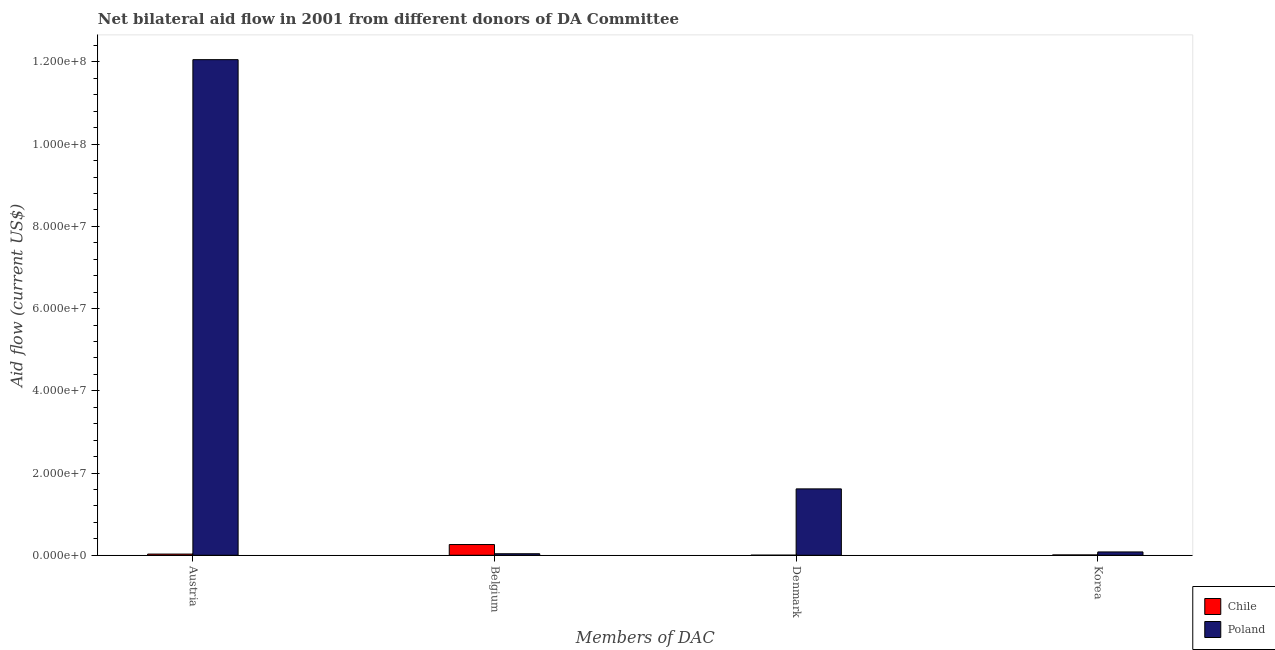How many different coloured bars are there?
Offer a very short reply. 2. Are the number of bars per tick equal to the number of legend labels?
Your answer should be very brief. Yes. How many bars are there on the 3rd tick from the right?
Your answer should be compact. 2. What is the amount of aid given by belgium in Chile?
Your answer should be very brief. 2.61e+06. Across all countries, what is the maximum amount of aid given by austria?
Give a very brief answer. 1.21e+08. Across all countries, what is the minimum amount of aid given by korea?
Keep it short and to the point. 8.00e+04. In which country was the amount of aid given by korea maximum?
Offer a terse response. Poland. In which country was the amount of aid given by belgium minimum?
Offer a very short reply. Poland. What is the total amount of aid given by korea in the graph?
Provide a short and direct response. 8.90e+05. What is the difference between the amount of aid given by denmark in Chile and that in Poland?
Ensure brevity in your answer.  -1.61e+07. What is the difference between the amount of aid given by austria in Poland and the amount of aid given by korea in Chile?
Your answer should be very brief. 1.20e+08. What is the average amount of aid given by korea per country?
Your response must be concise. 4.45e+05. What is the difference between the amount of aid given by belgium and amount of aid given by korea in Poland?
Provide a short and direct response. -4.40e+05. In how many countries, is the amount of aid given by austria greater than 80000000 US$?
Offer a very short reply. 1. What is the ratio of the amount of aid given by belgium in Poland to that in Chile?
Provide a short and direct response. 0.14. Is the difference between the amount of aid given by belgium in Poland and Chile greater than the difference between the amount of aid given by denmark in Poland and Chile?
Your response must be concise. No. What is the difference between the highest and the second highest amount of aid given by denmark?
Offer a terse response. 1.61e+07. What is the difference between the highest and the lowest amount of aid given by denmark?
Provide a succinct answer. 1.61e+07. Is it the case that in every country, the sum of the amount of aid given by korea and amount of aid given by austria is greater than the sum of amount of aid given by denmark and amount of aid given by belgium?
Keep it short and to the point. No. What does the 1st bar from the right in Belgium represents?
Give a very brief answer. Poland. How many bars are there?
Keep it short and to the point. 8. What is the difference between two consecutive major ticks on the Y-axis?
Your response must be concise. 2.00e+07. Are the values on the major ticks of Y-axis written in scientific E-notation?
Give a very brief answer. Yes. Where does the legend appear in the graph?
Keep it short and to the point. Bottom right. How are the legend labels stacked?
Your response must be concise. Vertical. What is the title of the graph?
Make the answer very short. Net bilateral aid flow in 2001 from different donors of DA Committee. What is the label or title of the X-axis?
Your answer should be compact. Members of DAC. What is the Aid flow (current US$) in Poland in Austria?
Give a very brief answer. 1.21e+08. What is the Aid flow (current US$) in Chile in Belgium?
Keep it short and to the point. 2.61e+06. What is the Aid flow (current US$) of Chile in Denmark?
Keep it short and to the point. 2.00e+04. What is the Aid flow (current US$) of Poland in Denmark?
Offer a very short reply. 1.62e+07. What is the Aid flow (current US$) of Poland in Korea?
Make the answer very short. 8.10e+05. Across all Members of DAC, what is the maximum Aid flow (current US$) of Chile?
Give a very brief answer. 2.61e+06. Across all Members of DAC, what is the maximum Aid flow (current US$) in Poland?
Offer a very short reply. 1.21e+08. What is the total Aid flow (current US$) of Poland in the graph?
Offer a terse response. 1.38e+08. What is the difference between the Aid flow (current US$) in Chile in Austria and that in Belgium?
Your response must be concise. -2.32e+06. What is the difference between the Aid flow (current US$) of Poland in Austria and that in Belgium?
Provide a short and direct response. 1.20e+08. What is the difference between the Aid flow (current US$) in Chile in Austria and that in Denmark?
Make the answer very short. 2.70e+05. What is the difference between the Aid flow (current US$) of Poland in Austria and that in Denmark?
Offer a very short reply. 1.04e+08. What is the difference between the Aid flow (current US$) of Poland in Austria and that in Korea?
Give a very brief answer. 1.20e+08. What is the difference between the Aid flow (current US$) of Chile in Belgium and that in Denmark?
Ensure brevity in your answer.  2.59e+06. What is the difference between the Aid flow (current US$) in Poland in Belgium and that in Denmark?
Your response must be concise. -1.58e+07. What is the difference between the Aid flow (current US$) in Chile in Belgium and that in Korea?
Make the answer very short. 2.53e+06. What is the difference between the Aid flow (current US$) in Poland in Belgium and that in Korea?
Your answer should be compact. -4.40e+05. What is the difference between the Aid flow (current US$) of Poland in Denmark and that in Korea?
Your answer should be very brief. 1.53e+07. What is the difference between the Aid flow (current US$) of Chile in Austria and the Aid flow (current US$) of Poland in Belgium?
Offer a very short reply. -8.00e+04. What is the difference between the Aid flow (current US$) in Chile in Austria and the Aid flow (current US$) in Poland in Denmark?
Give a very brief answer. -1.59e+07. What is the difference between the Aid flow (current US$) in Chile in Austria and the Aid flow (current US$) in Poland in Korea?
Your response must be concise. -5.20e+05. What is the difference between the Aid flow (current US$) in Chile in Belgium and the Aid flow (current US$) in Poland in Denmark?
Make the answer very short. -1.35e+07. What is the difference between the Aid flow (current US$) in Chile in Belgium and the Aid flow (current US$) in Poland in Korea?
Offer a terse response. 1.80e+06. What is the difference between the Aid flow (current US$) of Chile in Denmark and the Aid flow (current US$) of Poland in Korea?
Offer a very short reply. -7.90e+05. What is the average Aid flow (current US$) in Chile per Members of DAC?
Keep it short and to the point. 7.50e+05. What is the average Aid flow (current US$) in Poland per Members of DAC?
Your response must be concise. 3.45e+07. What is the difference between the Aid flow (current US$) of Chile and Aid flow (current US$) of Poland in Austria?
Provide a succinct answer. -1.20e+08. What is the difference between the Aid flow (current US$) in Chile and Aid flow (current US$) in Poland in Belgium?
Make the answer very short. 2.24e+06. What is the difference between the Aid flow (current US$) of Chile and Aid flow (current US$) of Poland in Denmark?
Offer a terse response. -1.61e+07. What is the difference between the Aid flow (current US$) in Chile and Aid flow (current US$) in Poland in Korea?
Offer a very short reply. -7.30e+05. What is the ratio of the Aid flow (current US$) of Poland in Austria to that in Belgium?
Offer a very short reply. 325.86. What is the ratio of the Aid flow (current US$) in Chile in Austria to that in Denmark?
Offer a very short reply. 14.5. What is the ratio of the Aid flow (current US$) of Poland in Austria to that in Denmark?
Give a very brief answer. 7.47. What is the ratio of the Aid flow (current US$) in Chile in Austria to that in Korea?
Your answer should be compact. 3.62. What is the ratio of the Aid flow (current US$) of Poland in Austria to that in Korea?
Give a very brief answer. 148.85. What is the ratio of the Aid flow (current US$) of Chile in Belgium to that in Denmark?
Make the answer very short. 130.5. What is the ratio of the Aid flow (current US$) in Poland in Belgium to that in Denmark?
Provide a short and direct response. 0.02. What is the ratio of the Aid flow (current US$) in Chile in Belgium to that in Korea?
Your response must be concise. 32.62. What is the ratio of the Aid flow (current US$) of Poland in Belgium to that in Korea?
Ensure brevity in your answer.  0.46. What is the ratio of the Aid flow (current US$) in Chile in Denmark to that in Korea?
Ensure brevity in your answer.  0.25. What is the ratio of the Aid flow (current US$) of Poland in Denmark to that in Korea?
Offer a terse response. 19.94. What is the difference between the highest and the second highest Aid flow (current US$) in Chile?
Offer a terse response. 2.32e+06. What is the difference between the highest and the second highest Aid flow (current US$) of Poland?
Provide a succinct answer. 1.04e+08. What is the difference between the highest and the lowest Aid flow (current US$) in Chile?
Your response must be concise. 2.59e+06. What is the difference between the highest and the lowest Aid flow (current US$) of Poland?
Keep it short and to the point. 1.20e+08. 